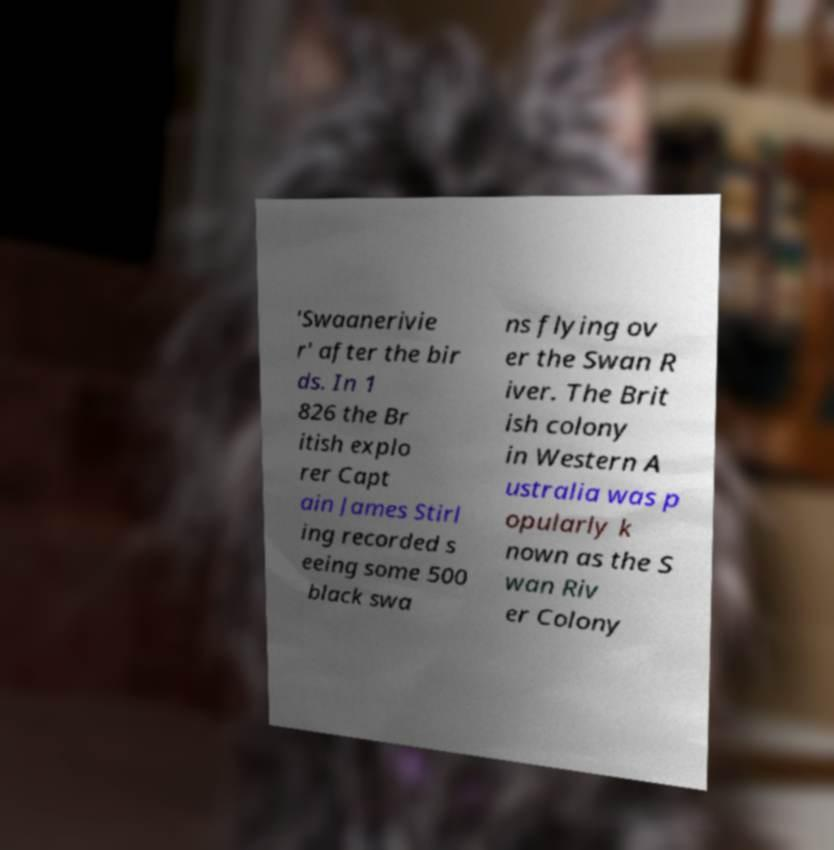For documentation purposes, I need the text within this image transcribed. Could you provide that? 'Swaanerivie r' after the bir ds. In 1 826 the Br itish explo rer Capt ain James Stirl ing recorded s eeing some 500 black swa ns flying ov er the Swan R iver. The Brit ish colony in Western A ustralia was p opularly k nown as the S wan Riv er Colony 